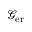Convert formula to latex. <formula><loc_0><loc_0><loc_500><loc_500>\ m a t h s c r { G } _ { e r }</formula> 